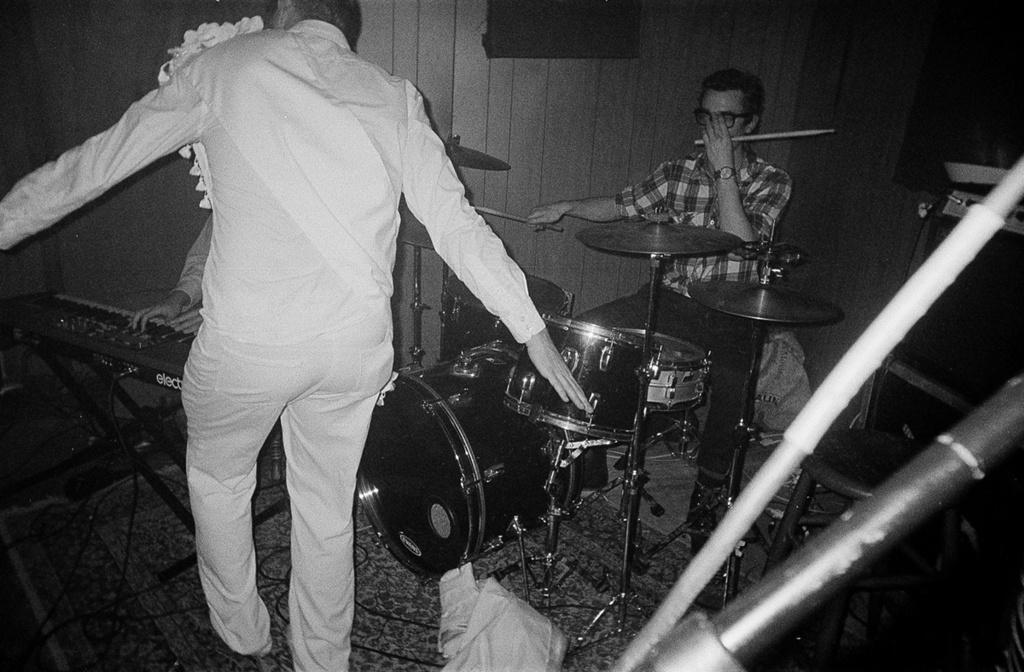What is the main subject of the image? The main subject of the image is a person sitting in front of drums. Are there any other people in the image? Yes, there is another person standing in front of the person sitting at the drums, and a third person playing the piano. What instruments are being played in the image? Drums and a piano are being played in the image. What type of crib is visible in the image? There is no crib present in the image. What thought is the person playing the piano having while performing? We cannot determine the thoughts of the person playing the piano from the image alone. 